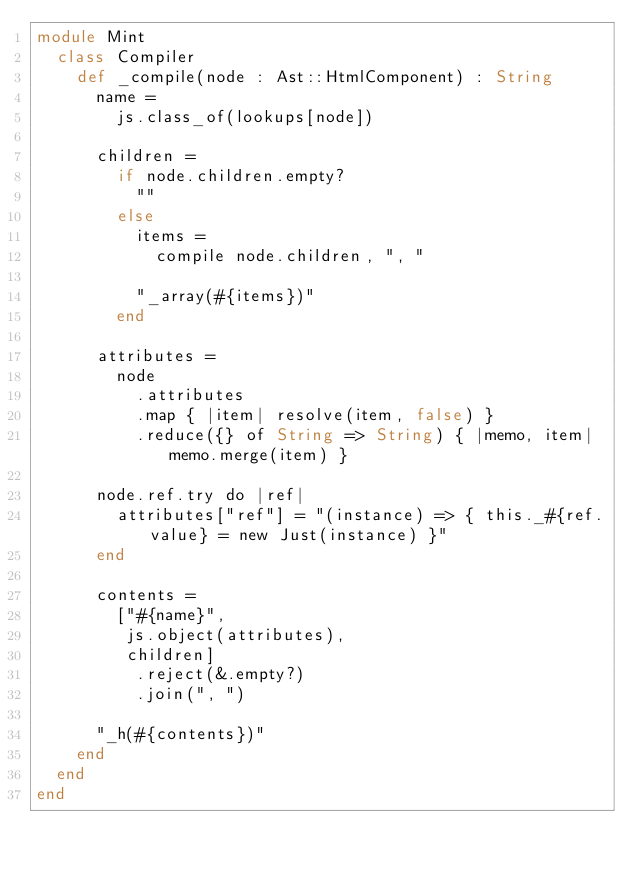Convert code to text. <code><loc_0><loc_0><loc_500><loc_500><_Crystal_>module Mint
  class Compiler
    def _compile(node : Ast::HtmlComponent) : String
      name =
        js.class_of(lookups[node])

      children =
        if node.children.empty?
          ""
        else
          items =
            compile node.children, ", "

          "_array(#{items})"
        end

      attributes =
        node
          .attributes
          .map { |item| resolve(item, false) }
          .reduce({} of String => String) { |memo, item| memo.merge(item) }

      node.ref.try do |ref|
        attributes["ref"] = "(instance) => { this._#{ref.value} = new Just(instance) }"
      end

      contents =
        ["#{name}",
         js.object(attributes),
         children]
          .reject(&.empty?)
          .join(", ")

      "_h(#{contents})"
    end
  end
end
</code> 